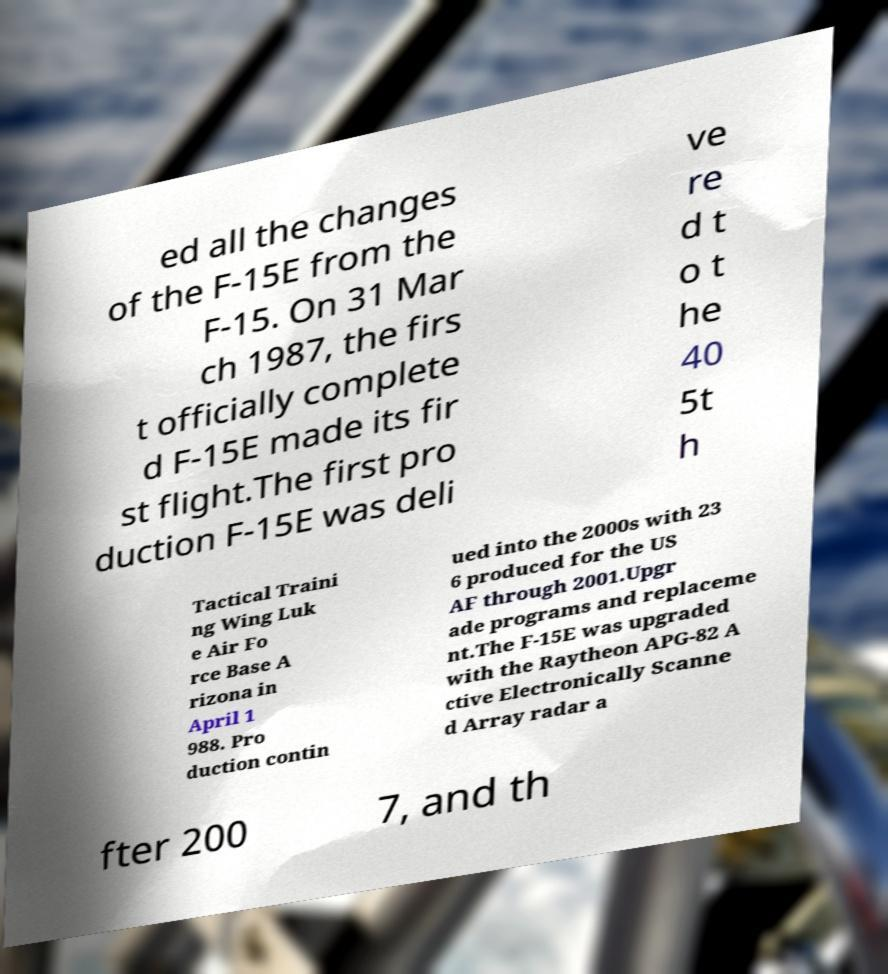Please identify and transcribe the text found in this image. ed all the changes of the F-15E from the F-15. On 31 Mar ch 1987, the firs t officially complete d F-15E made its fir st flight.The first pro duction F-15E was deli ve re d t o t he 40 5t h Tactical Traini ng Wing Luk e Air Fo rce Base A rizona in April 1 988. Pro duction contin ued into the 2000s with 23 6 produced for the US AF through 2001.Upgr ade programs and replaceme nt.The F-15E was upgraded with the Raytheon APG-82 A ctive Electronically Scanne d Array radar a fter 200 7, and th 